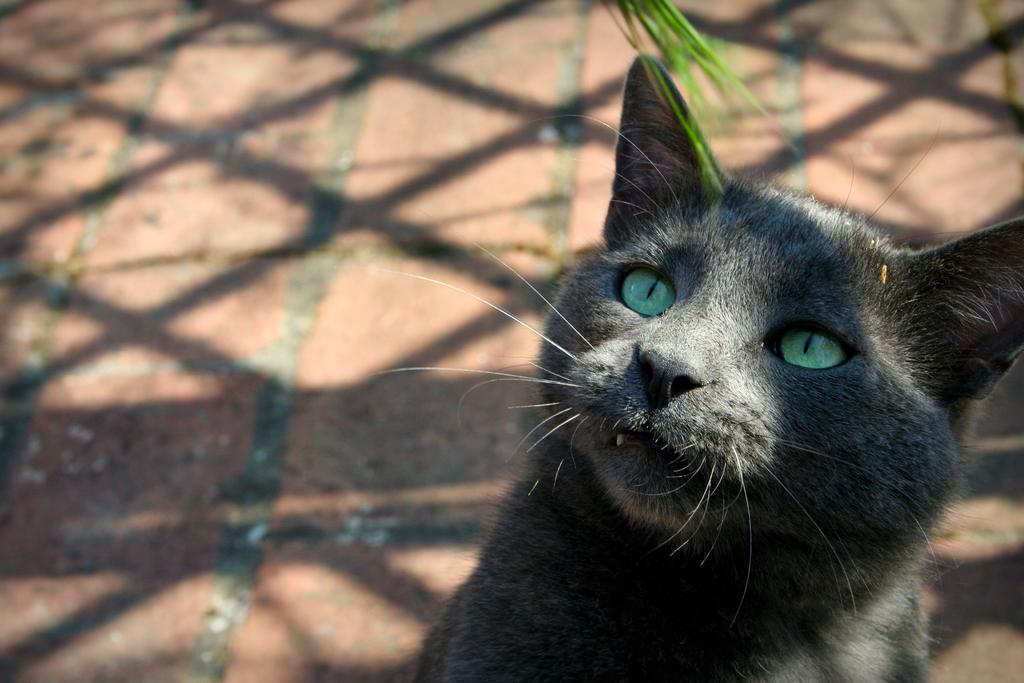What type of animal is in the image? There is a cat in the image. What color are the cat's eyes? The cat's eyes are in light blue color. What type of ice can be seen melting near the cat in the image? There is no ice present in the image; it only features a cat with light blue eyes. 